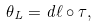<formula> <loc_0><loc_0><loc_500><loc_500>\theta _ { L } = d \ell \circ \tau ,</formula> 